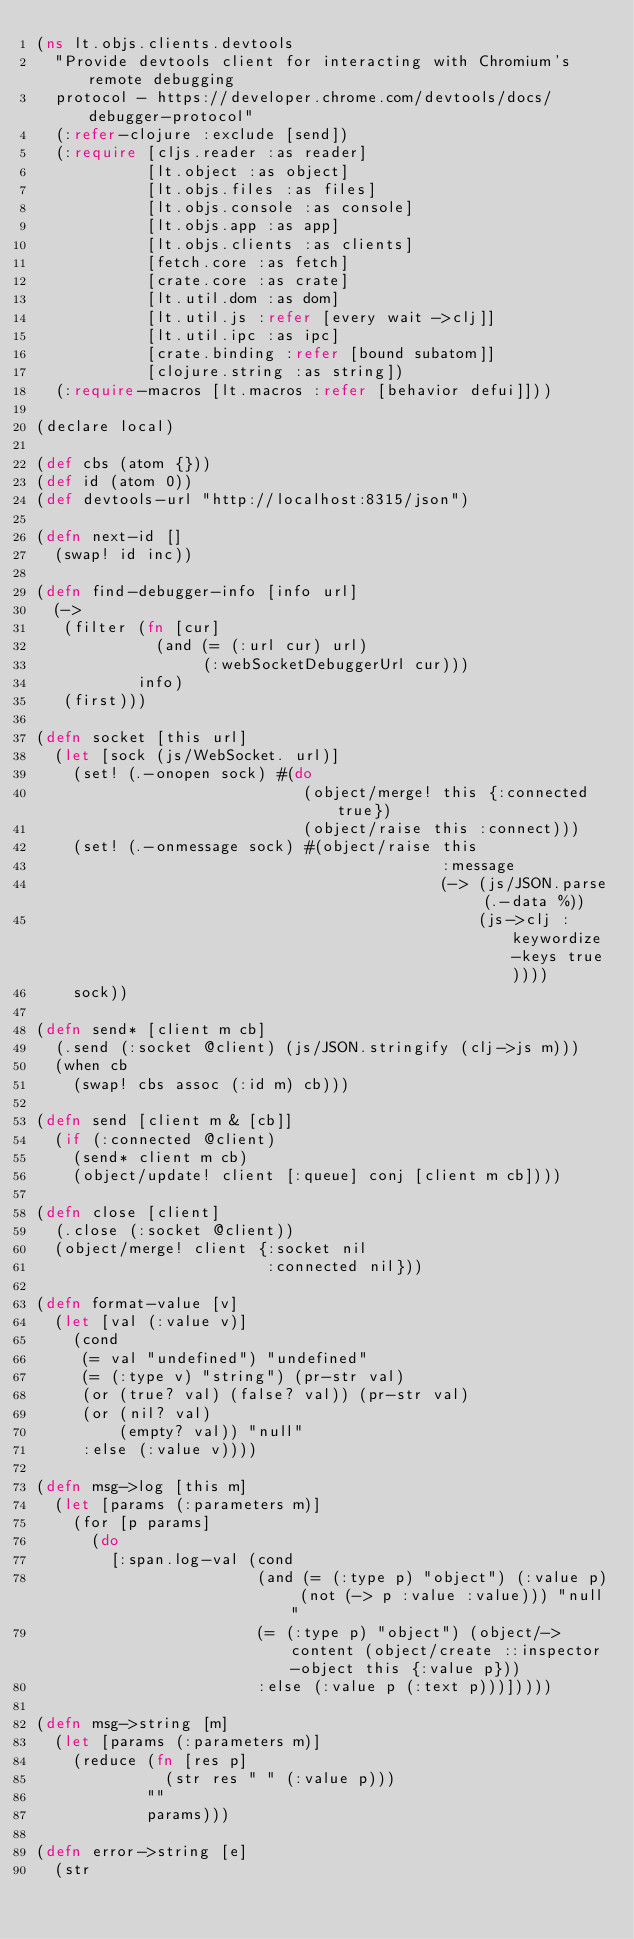Convert code to text. <code><loc_0><loc_0><loc_500><loc_500><_Clojure_>(ns lt.objs.clients.devtools
  "Provide devtools client for interacting with Chromium's remote debugging
  protocol - https://developer.chrome.com/devtools/docs/debugger-protocol"
  (:refer-clojure :exclude [send])
  (:require [cljs.reader :as reader]
            [lt.object :as object]
            [lt.objs.files :as files]
            [lt.objs.console :as console]
            [lt.objs.app :as app]
            [lt.objs.clients :as clients]
            [fetch.core :as fetch]
            [crate.core :as crate]
            [lt.util.dom :as dom]
            [lt.util.js :refer [every wait ->clj]]
            [lt.util.ipc :as ipc]
            [crate.binding :refer [bound subatom]]
            [clojure.string :as string])
  (:require-macros [lt.macros :refer [behavior defui]]))

(declare local)

(def cbs (atom {}))
(def id (atom 0))
(def devtools-url "http://localhost:8315/json")

(defn next-id []
  (swap! id inc))

(defn find-debugger-info [info url]
  (->
   (filter (fn [cur]
             (and (= (:url cur) url)
                  (:webSocketDebuggerUrl cur)))
           info)
   (first)))

(defn socket [this url]
  (let [sock (js/WebSocket. url)]
    (set! (.-onopen sock) #(do
                             (object/merge! this {:connected true})
                             (object/raise this :connect)))
    (set! (.-onmessage sock) #(object/raise this
                                            :message
                                            (-> (js/JSON.parse (.-data %))
                                                (js->clj :keywordize-keys true))))
    sock))

(defn send* [client m cb]
  (.send (:socket @client) (js/JSON.stringify (clj->js m)))
  (when cb
    (swap! cbs assoc (:id m) cb)))

(defn send [client m & [cb]]
  (if (:connected @client)
    (send* client m cb)
    (object/update! client [:queue] conj [client m cb])))

(defn close [client]
  (.close (:socket @client))
  (object/merge! client {:socket nil
                         :connected nil}))

(defn format-value [v]
  (let [val (:value v)]
    (cond
     (= val "undefined") "undefined"
     (= (:type v) "string") (pr-str val)
     (or (true? val) (false? val)) (pr-str val)
     (or (nil? val)
         (empty? val)) "null"
     :else (:value v))))

(defn msg->log [this m]
  (let [params (:parameters m)]
    (for [p params]
      (do
        [:span.log-val (cond
                        (and (= (:type p) "object") (:value p) (not (-> p :value :value))) "null"
                        (= (:type p) "object") (object/->content (object/create ::inspector-object this {:value p}))
                        :else (:value p (:text p)))]))))

(defn msg->string [m]
  (let [params (:parameters m)]
    (reduce (fn [res p]
              (str res " " (:value p)))
            ""
            params)))

(defn error->string [e]
  (str</code> 